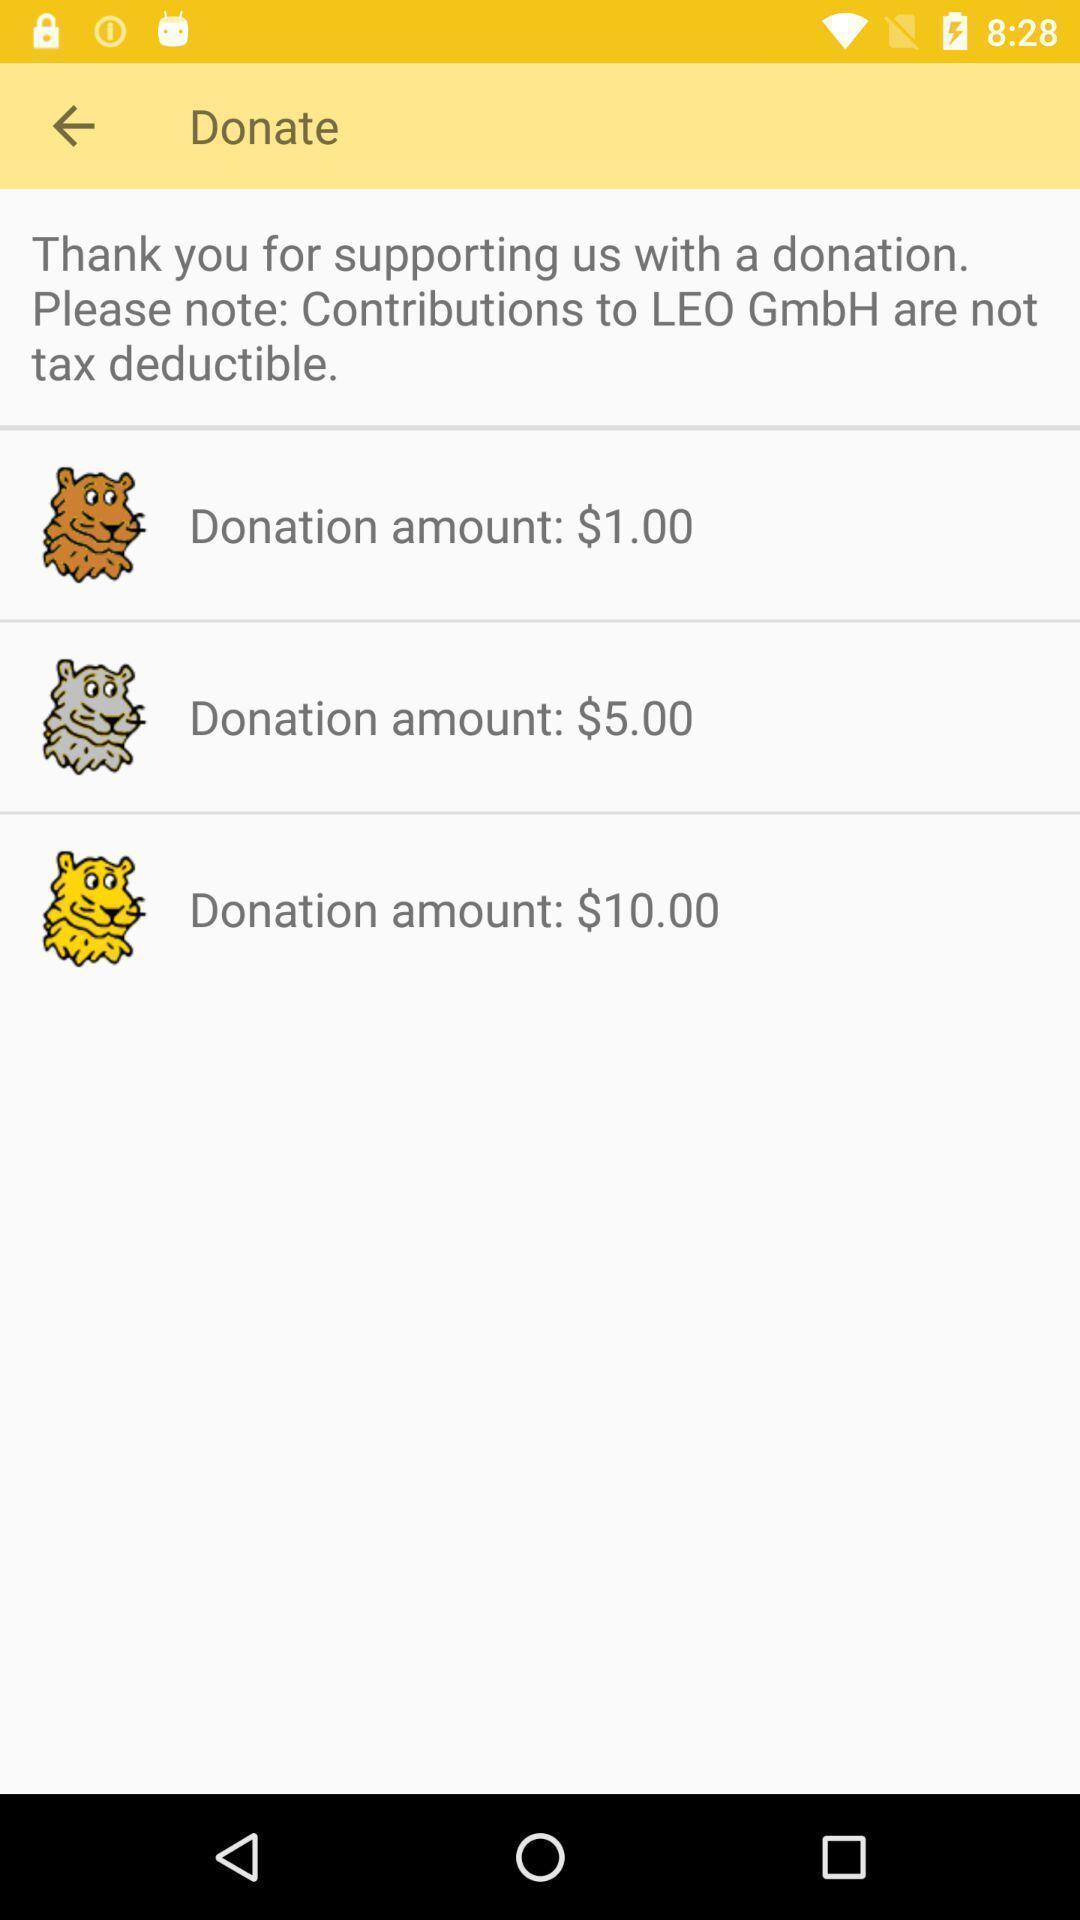Tell me what you see in this picture. Page displaying the donation amount list. 